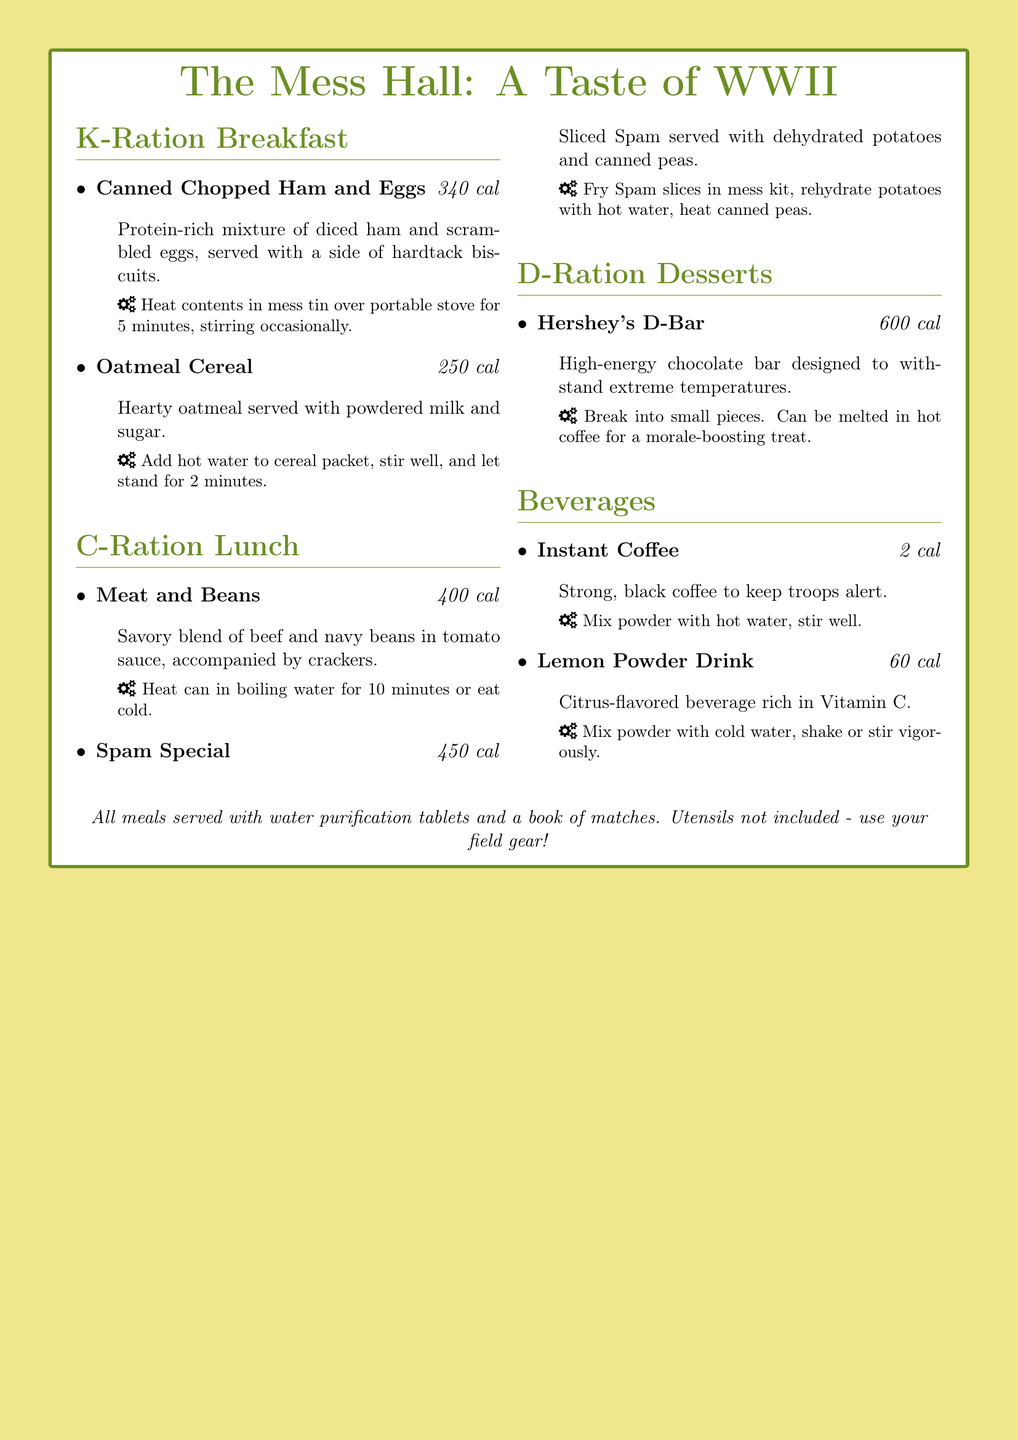What is the calorie count for Canned Chopped Ham and Eggs? The calorie count is specifically listed in the menu under that item.
Answer: 340 cal How long should you heat the Meat and Beans can? The preparation instructions indicate the specific heating time for this meal.
Answer: 10 minutes What beverage is rich in Vitamin C? The menu details which beverages provide this nutritional benefit.
Answer: Lemon Powder Drink How many calories does the Spam Special contain? The calorie content is provided for each meal on the menu.
Answer: 450 cal Which dessert has the highest calorie count? By comparing the calorie counts of the desserts listed, one can determine which has the highest.
Answer: Hershey's D-Bar What is the preparation method for the Oatmeal Cereal? The document outlines specific steps for preparing this meal.
Answer: Add hot water to cereal packet, stir well, and let stand for 2 minutes What item is served with a side of hardtack biscuits? The accompanying items for each meal are detailed in the menu.
Answer: Canned Chopped Ham and Eggs How many calories does Instant Coffee provide? The menu lists the calorie information for each beverage item.
Answer: 2 cal 